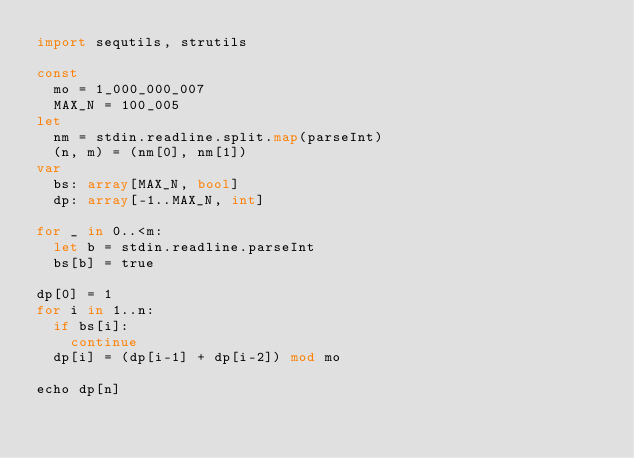<code> <loc_0><loc_0><loc_500><loc_500><_Nim_>import sequtils, strutils

const
  mo = 1_000_000_007
  MAX_N = 100_005
let
  nm = stdin.readline.split.map(parseInt)
  (n, m) = (nm[0], nm[1])
var
  bs: array[MAX_N, bool]
  dp: array[-1..MAX_N, int]

for _ in 0..<m:
  let b = stdin.readline.parseInt
  bs[b] = true

dp[0] = 1
for i in 1..n:
  if bs[i]:
    continue
  dp[i] = (dp[i-1] + dp[i-2]) mod mo

echo dp[n]
</code> 